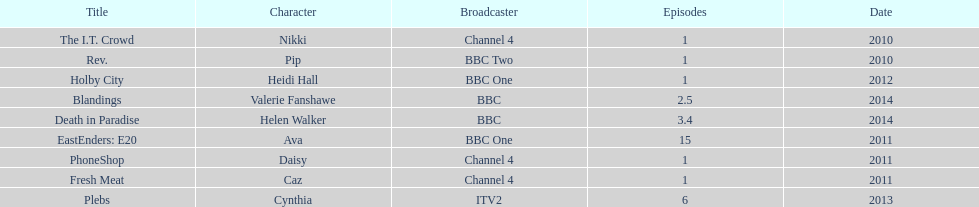What roles did she play? Pip, Nikki, Ava, Caz, Daisy, Heidi Hall, Cynthia, Valerie Fanshawe, Helen Walker. On which broadcasters? BBC Two, Channel 4, BBC One, Channel 4, Channel 4, BBC One, ITV2, BBC, BBC. Which roles did she play for itv2? Cynthia. 